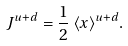Convert formula to latex. <formula><loc_0><loc_0><loc_500><loc_500>J ^ { u + d } = \frac { 1 } { 2 } \, \langle x \rangle ^ { u + d } .</formula> 